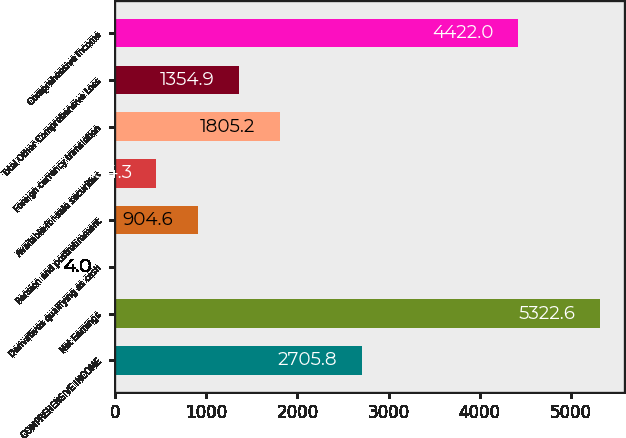Convert chart to OTSL. <chart><loc_0><loc_0><loc_500><loc_500><bar_chart><fcel>COMPREHENSIVE INCOME<fcel>Net Earnings<fcel>Derivatives qualifying as cash<fcel>Pension and postretirement<fcel>Available-for-sale securities<fcel>Foreign currency translation<fcel>Total Other Comprehensive Loss<fcel>Comprehensive Income<nl><fcel>2705.8<fcel>5322.6<fcel>4<fcel>904.6<fcel>454.3<fcel>1805.2<fcel>1354.9<fcel>4422<nl></chart> 